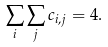Convert formula to latex. <formula><loc_0><loc_0><loc_500><loc_500>\sum _ { i } \sum _ { j } c _ { i , j } = 4 .</formula> 